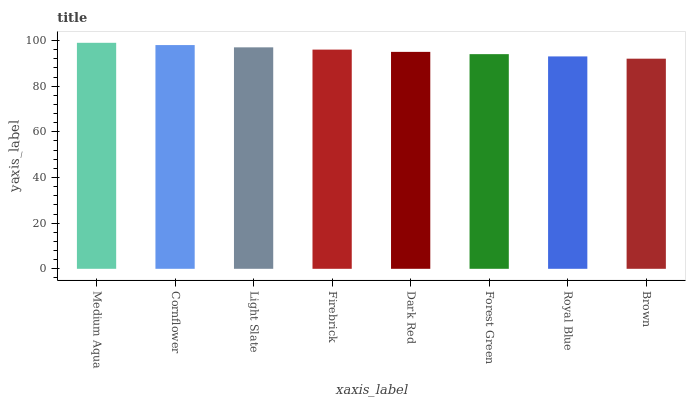Is Brown the minimum?
Answer yes or no. Yes. Is Medium Aqua the maximum?
Answer yes or no. Yes. Is Cornflower the minimum?
Answer yes or no. No. Is Cornflower the maximum?
Answer yes or no. No. Is Medium Aqua greater than Cornflower?
Answer yes or no. Yes. Is Cornflower less than Medium Aqua?
Answer yes or no. Yes. Is Cornflower greater than Medium Aqua?
Answer yes or no. No. Is Medium Aqua less than Cornflower?
Answer yes or no. No. Is Firebrick the high median?
Answer yes or no. Yes. Is Dark Red the low median?
Answer yes or no. Yes. Is Brown the high median?
Answer yes or no. No. Is Royal Blue the low median?
Answer yes or no. No. 